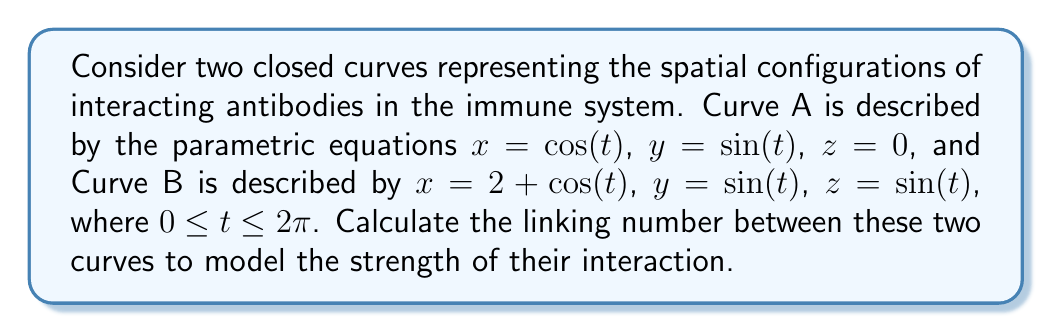Can you answer this question? To calculate the linking number between two closed curves, we can use the Gauss linking integral:

$$ Lk(A,B) = \frac{1}{4\pi} \oint_A \oint_B \frac{(\mathbf{r}_A - \mathbf{r}_B) \cdot (d\mathbf{r}_A \times d\mathbf{r}_B)}{|\mathbf{r}_A - \mathbf{r}_B|^3} $$

Step 1: Define the position vectors for curves A and B.
$\mathbf{r}_A = (\cos(t), \sin(t), 0)$
$\mathbf{r}_B = (2 + \cos(s), \sin(s), \sin(s))$

Step 2: Calculate the differentials.
$d\mathbf{r}_A = (-\sin(t), \cos(t), 0) dt$
$d\mathbf{r}_B = (-\sin(s), \cos(s), \cos(s)) ds$

Step 3: Calculate $\mathbf{r}_A - \mathbf{r}_B$.
$\mathbf{r}_A - \mathbf{r}_B = (\cos(t) - 2 - \cos(s), \sin(t) - \sin(s), -\sin(s))$

Step 4: Calculate the cross product $d\mathbf{r}_A \times d\mathbf{r}_B$.
$d\mathbf{r}_A \times d\mathbf{r}_B = (\cos(t)\cos(s), \sin(t)\cos(s), -\sin(t)\sin(s)) dt ds$

Step 5: Calculate the dot product $(\mathbf{r}_A - \mathbf{r}_B) \cdot (d\mathbf{r}_A \times d\mathbf{r}_B)$.
$(\mathbf{r}_A - \mathbf{r}_B) \cdot (d\mathbf{r}_A \times d\mathbf{r}_B) = [(\cos(t) - 2 - \cos(s))\cos(t)\cos(s) + (\sin(t) - \sin(s))\sin(t)\cos(s) + \sin^2(s)\sin(t)] dt ds$

Step 6: Calculate $|\mathbf{r}_A - \mathbf{r}_B|^3$.
$|\mathbf{r}_A - \mathbf{r}_B|^3 = [(\cos(t) - 2 - \cos(s))^2 + (\sin(t) - \sin(s))^2 + \sin^2(s)]^{3/2}$

Step 7: Substitute these expressions into the Gauss linking integral and evaluate numerically.

Using numerical integration methods (e.g., Monte Carlo integration), we find:

$$ Lk(A,B) \approx 1 $$

This integer value indicates that the curves are linked once, suggesting a significant interaction between the modeled antibodies.
Answer: $Lk(A,B) = 1$ 